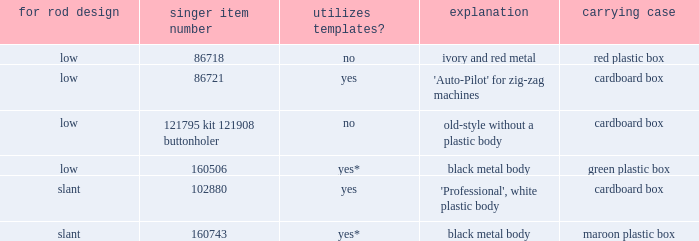What are all the different descriptions for the buttonholer with cardboard box for storage and a low shank type? 'Auto-Pilot' for zig-zag machines, old-style without a plastic body. 